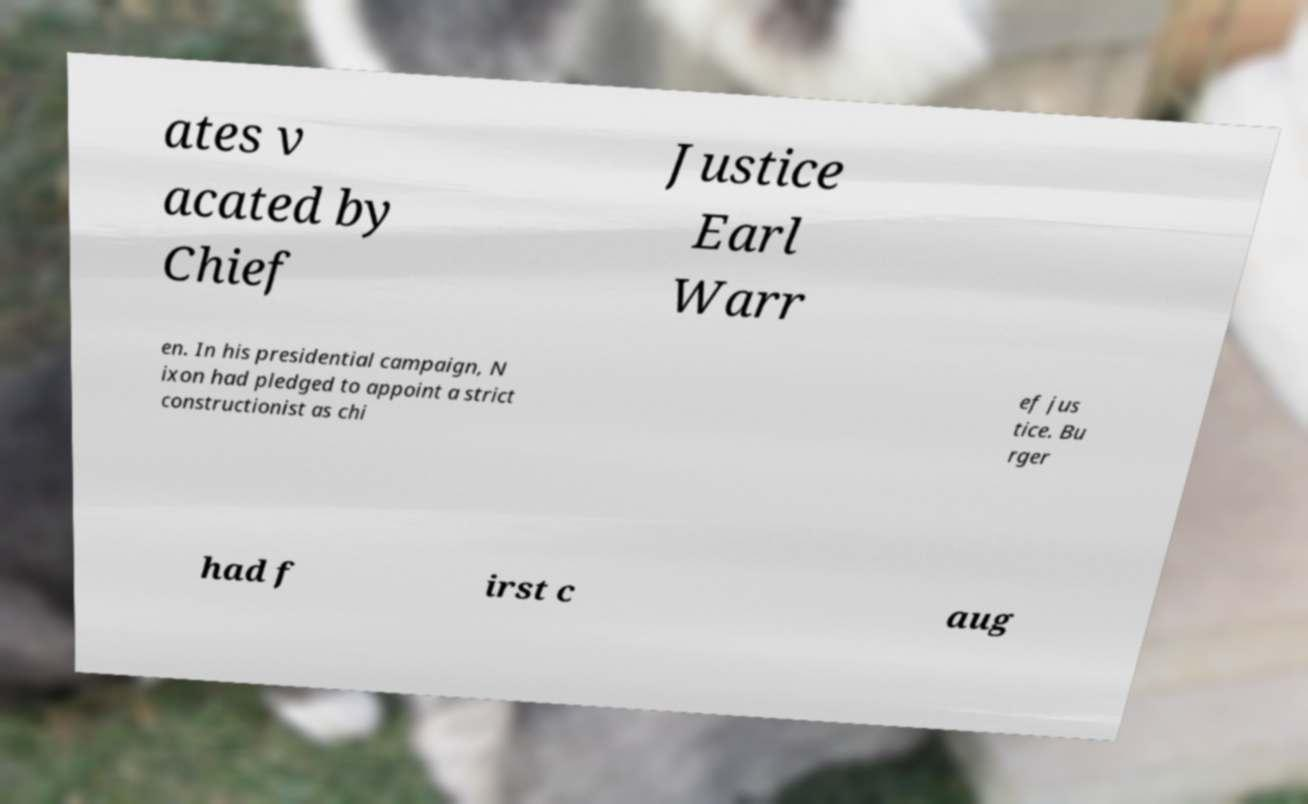There's text embedded in this image that I need extracted. Can you transcribe it verbatim? ates v acated by Chief Justice Earl Warr en. In his presidential campaign, N ixon had pledged to appoint a strict constructionist as chi ef jus tice. Bu rger had f irst c aug 